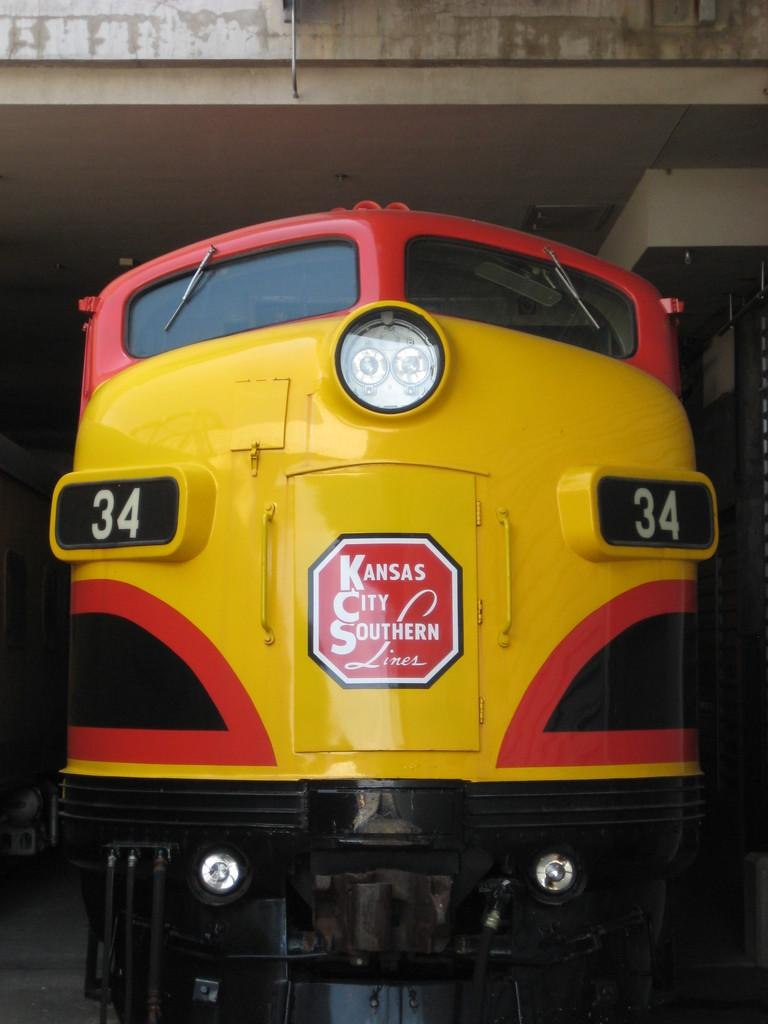What is the main subject of the image? The main subject of the image is a train engine. What can be seen above the train engine in the image? There is a ceiling at the top of the image. What type of quince is hanging from the ceiling in the image? There is no quince present in the image; it only features a train engine and a ceiling. 